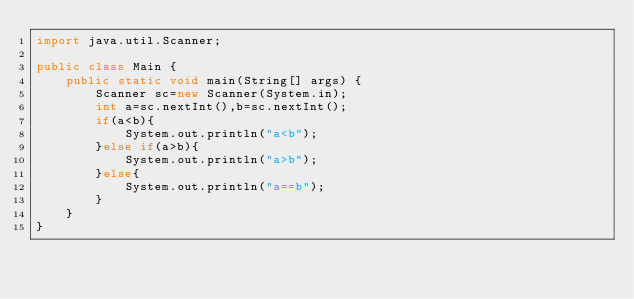Convert code to text. <code><loc_0><loc_0><loc_500><loc_500><_Java_>import java.util.Scanner;

public class Main {
	public static void main(String[] args) {
		Scanner sc=new Scanner(System.in);
		int a=sc.nextInt(),b=sc.nextInt();
		if(a<b){
			System.out.println("a<b");
		}else if(a>b){
			System.out.println("a>b");
		}else{
			System.out.println("a==b");
		}
	}
}
</code> 